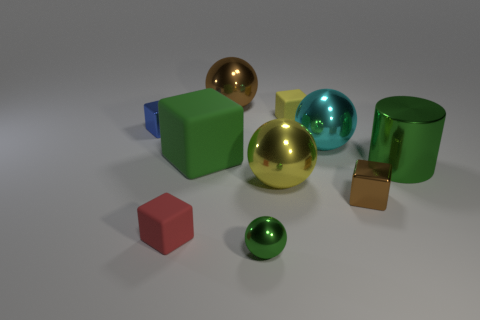Subtract all brown balls. How many balls are left? 3 Subtract all yellow rubber cubes. How many cubes are left? 4 Subtract all cylinders. How many objects are left? 9 Subtract all gray spheres. Subtract all cyan cubes. How many spheres are left? 4 Subtract all cyan cubes. How many purple spheres are left? 0 Subtract all green spheres. Subtract all big yellow metallic spheres. How many objects are left? 8 Add 3 big cyan metallic objects. How many big cyan metallic objects are left? 4 Add 2 small yellow shiny balls. How many small yellow shiny balls exist? 2 Subtract 0 cyan cylinders. How many objects are left? 10 Subtract 3 spheres. How many spheres are left? 1 